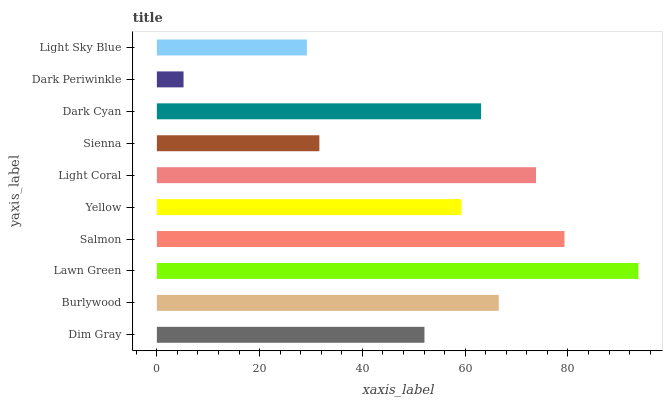Is Dark Periwinkle the minimum?
Answer yes or no. Yes. Is Lawn Green the maximum?
Answer yes or no. Yes. Is Burlywood the minimum?
Answer yes or no. No. Is Burlywood the maximum?
Answer yes or no. No. Is Burlywood greater than Dim Gray?
Answer yes or no. Yes. Is Dim Gray less than Burlywood?
Answer yes or no. Yes. Is Dim Gray greater than Burlywood?
Answer yes or no. No. Is Burlywood less than Dim Gray?
Answer yes or no. No. Is Dark Cyan the high median?
Answer yes or no. Yes. Is Yellow the low median?
Answer yes or no. Yes. Is Dark Periwinkle the high median?
Answer yes or no. No. Is Burlywood the low median?
Answer yes or no. No. 